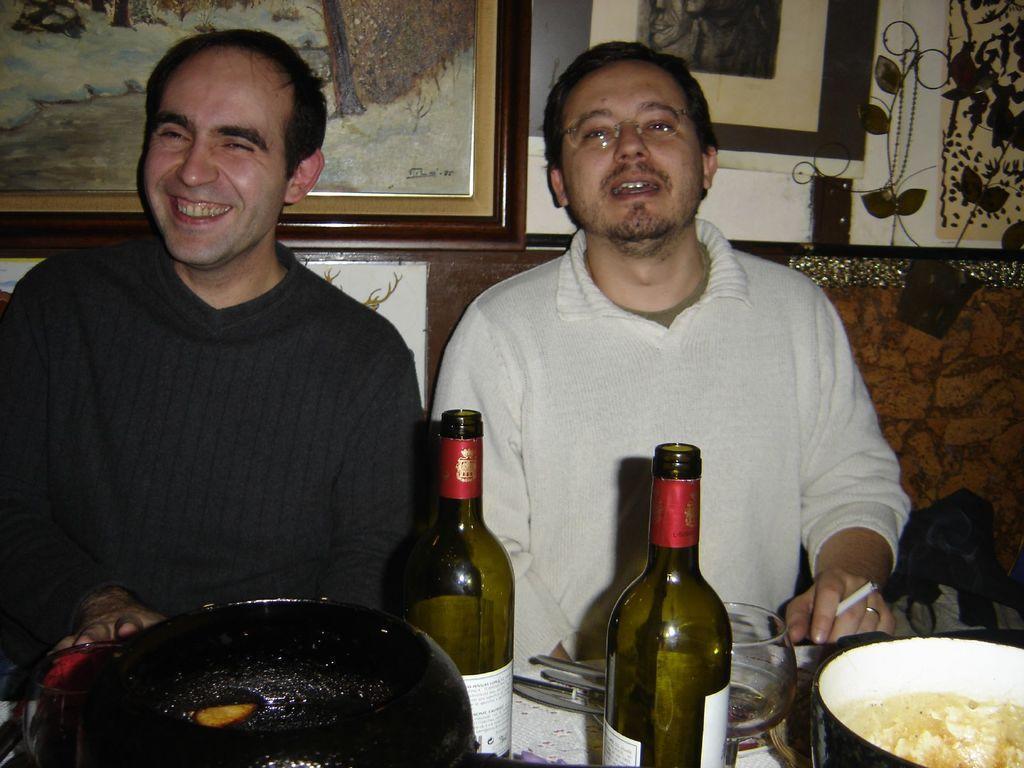Describe this image in one or two sentences. As we can see in the image there are photo frames and two people sitting on sofa and there is a table. On table there are bowls, glasses and bottle. 